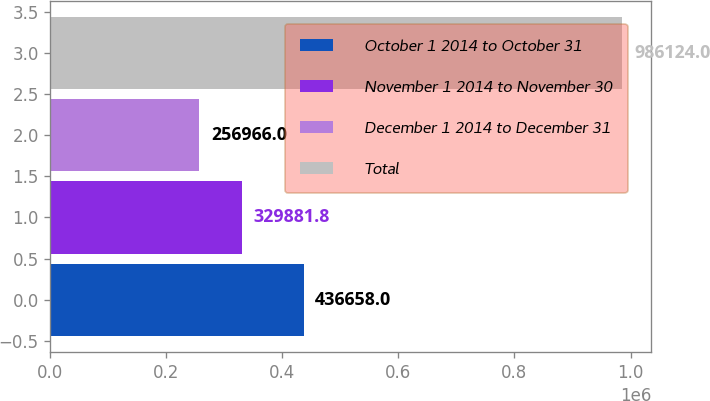Convert chart. <chart><loc_0><loc_0><loc_500><loc_500><bar_chart><fcel>October 1 2014 to October 31<fcel>November 1 2014 to November 30<fcel>December 1 2014 to December 31<fcel>Total<nl><fcel>436658<fcel>329882<fcel>256966<fcel>986124<nl></chart> 